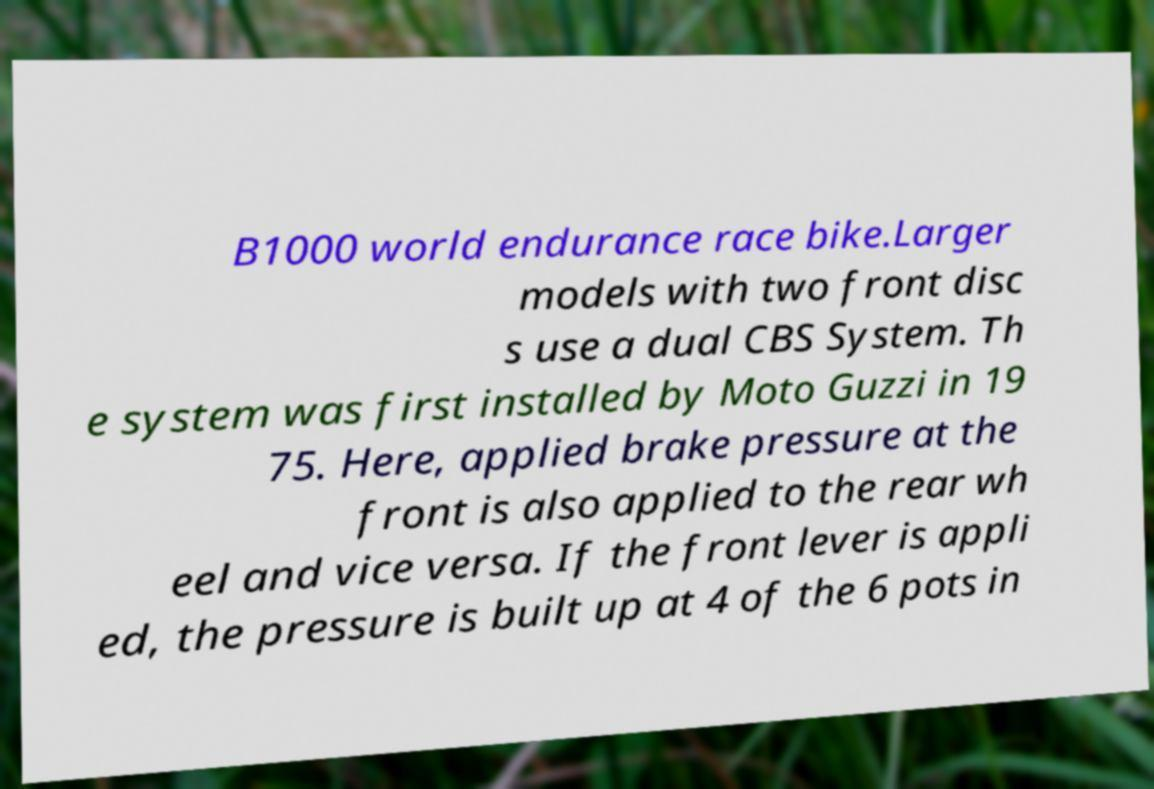Could you extract and type out the text from this image? B1000 world endurance race bike.Larger models with two front disc s use a dual CBS System. Th e system was first installed by Moto Guzzi in 19 75. Here, applied brake pressure at the front is also applied to the rear wh eel and vice versa. If the front lever is appli ed, the pressure is built up at 4 of the 6 pots in 